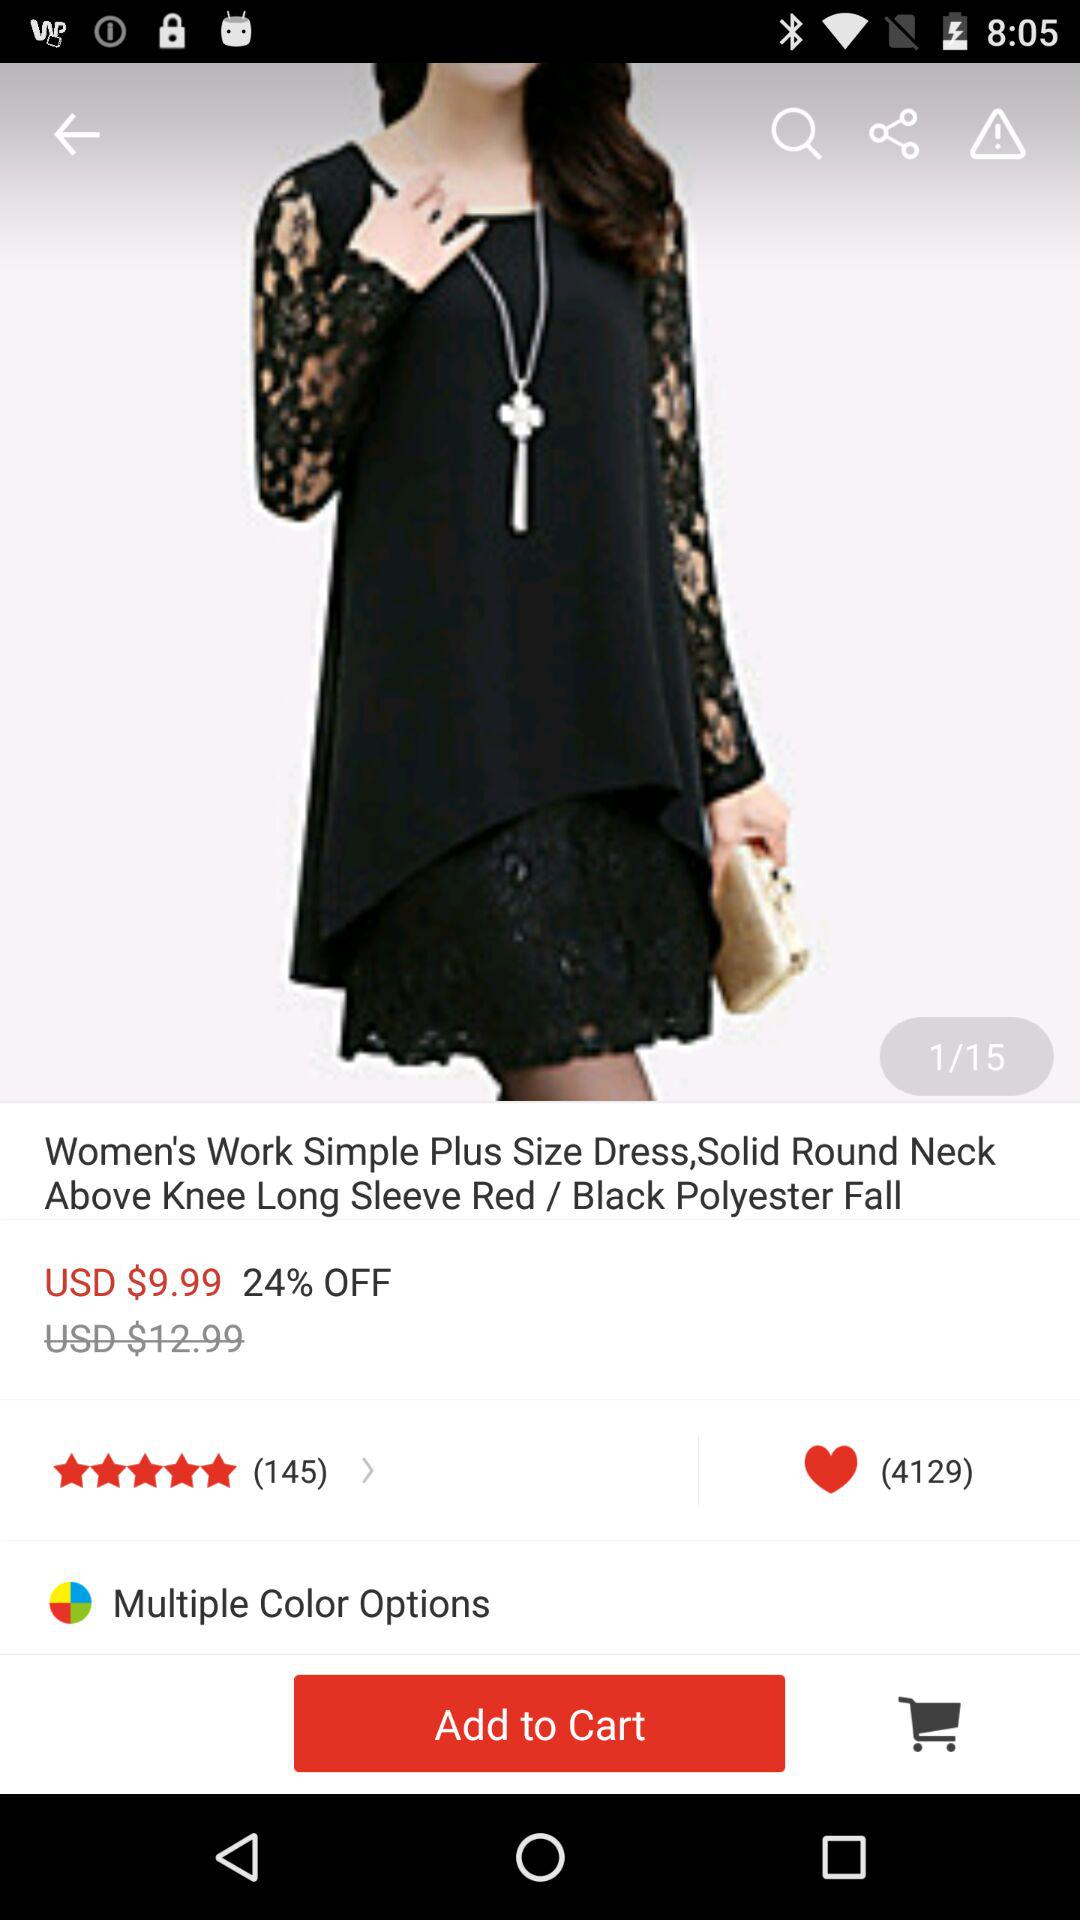Which tabs have been selected? The tabs that have been selected are "Shopping" and "Personal Flow". 